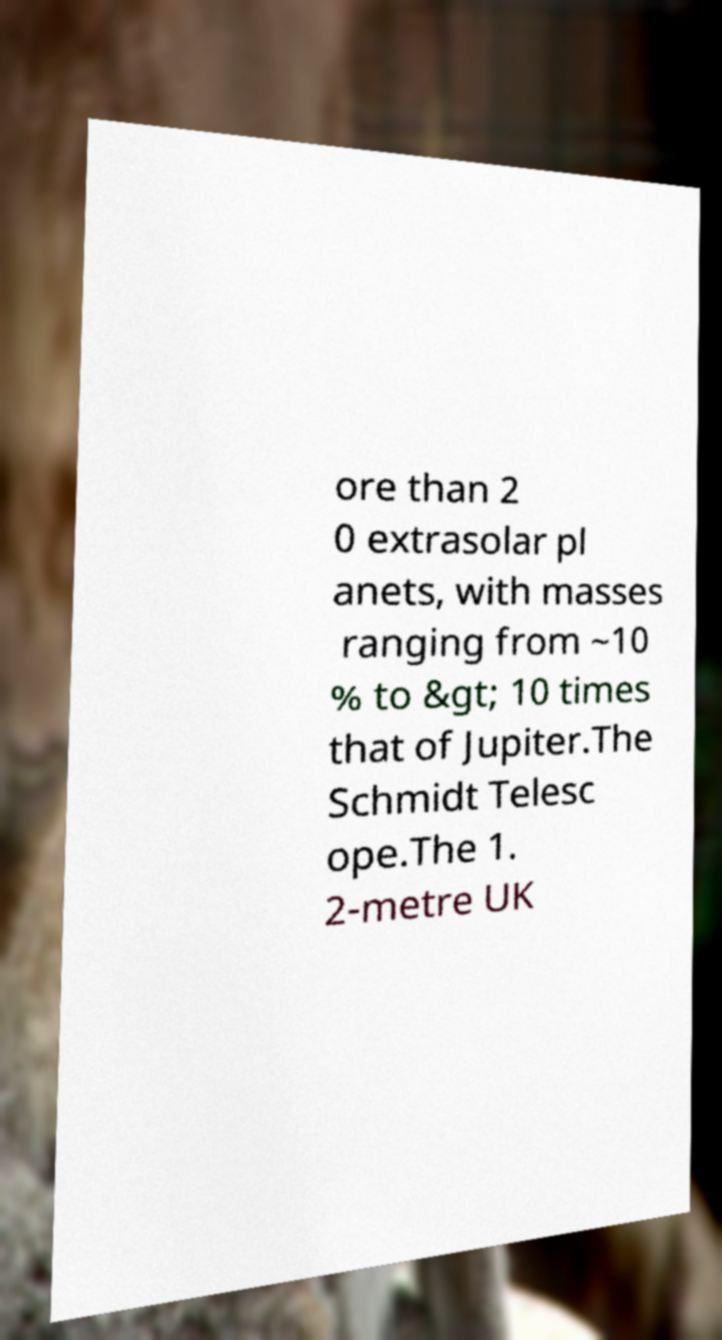Please identify and transcribe the text found in this image. ore than 2 0 extrasolar pl anets, with masses ranging from ~10 % to &gt; 10 times that of Jupiter.The Schmidt Telesc ope.The 1. 2-metre UK 